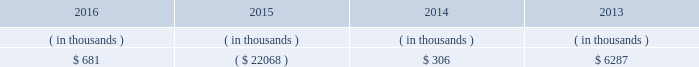Entergy texas , inc .
And subsidiaries management 2019s financial discussion and analysis in addition to the contractual obligations given above , entergy texas expects to contribute approximately $ 17 million to its qualified pension plans and approximately $ 3.2 million to other postretirement health care and life insurance plans in 2017 , although the 2017 required pension contributions will be known with more certainty when the january 1 , 2017 valuations are completed , which is expected by april 1 , 2017 .
See 201ccritical accounting estimates - qualified pension and other postretirement benefits 201d below for a discussion of qualified pension and other postretirement benefits funding .
Also in addition to the contractual obligations , entergy texas has $ 15.6 million of unrecognized tax benefits and interest net of unused tax attributes and payments for which the timing of payments beyond 12 months cannot be reasonably estimated due to uncertainties in the timing of effective settlement of tax positions .
See note 3 to the financial statements for additional information regarding unrecognized tax benefits .
In addition to routine capital spending to maintain operations , the planned capital investment estimate for entergy texas includes specific investments such as the montgomery county power station discussed below ; transmission projects to enhance reliability , reduce congestion , and enable economic growth ; distribution spending to enhance reliability and improve service to customers , including initial investment to support advanced metering ; system improvements ; and other investments .
Estimated capital expenditures are subject to periodic review and modification and may vary based on the ongoing effects of regulatory constraints and requirements , environmental compliance , business opportunities , market volatility , economic trends , business restructuring , changes in project plans , and the ability to access capital .
Management provides more information on long-term debt in note 5 to the financial statements .
As discussed above in 201ccapital structure , 201d entergy texas routinely evaluates its ability to pay dividends to entergy corporation from its earnings .
Sources of capital entergy texas 2019s sources to meet its capital requirements include : 2022 internally generated funds ; 2022 cash on hand ; 2022 debt or preferred stock issuances ; and 2022 bank financing under new or existing facilities .
Entergy texas may refinance , redeem , or otherwise retire debt prior to maturity , to the extent market conditions and interest and dividend rates are favorable .
All debt and common and preferred stock issuances by entergy texas require prior regulatory approval .
Debt issuances are also subject to issuance tests set forth in its bond indenture and other agreements .
Entergy texas has sufficient capacity under these tests to meet its foreseeable capital needs .
Entergy texas 2019s receivables from or ( payables to ) the money pool were as follows as of december 31 for each of the following years. .
See note 4 to the financial statements for a description of the money pool .
Entergy texas has a credit facility in the amount of $ 150 million scheduled to expire in august 2021 .
The credit facility allows entergy texas to issue letters of credit against 50% ( 50 % ) of the borrowing capacity of the facility .
As of december 31 , 2016 , there were no cash borrowings and $ 4.7 million of letters of credit outstanding under the credit facility .
In addition , entergy texas is a party to an uncommitted letter of credit facility as a means to post collateral .
What is the dollar amount in millions of letters of credit that can be issued under the august 2021 credit facility? 
Computations: (150 * 50%)
Answer: 75.0. 